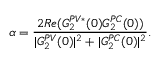Convert formula to latex. <formula><loc_0><loc_0><loc_500><loc_500>\alpha = \frac { 2 R e ( G _ { 2 } ^ { P V * } ( 0 ) G _ { 2 } ^ { P C } ( 0 ) ) } { | G _ { 2 } ^ { P V } ( 0 ) | ^ { 2 } + | G _ { 2 } ^ { P C } ( 0 ) | ^ { 2 } } .</formula> 